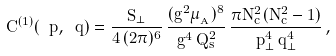<formula> <loc_0><loc_0><loc_500><loc_500>C ^ { ( 1 ) } ( \ p , \ q ) = \frac { S _ { \perp } } { 4 \, ( 2 \pi ) ^ { 6 } } \, \frac { ( g ^ { 2 } \mu _ { _ { A } } ) ^ { 8 } } { g ^ { 4 } \, Q _ { s } ^ { 2 } } \, \frac { \pi N _ { c } ^ { 2 } ( N _ { c } ^ { 2 } - 1 ) } { p _ { \perp } ^ { 4 } \, q _ { \perp } ^ { 4 } } \, ,</formula> 